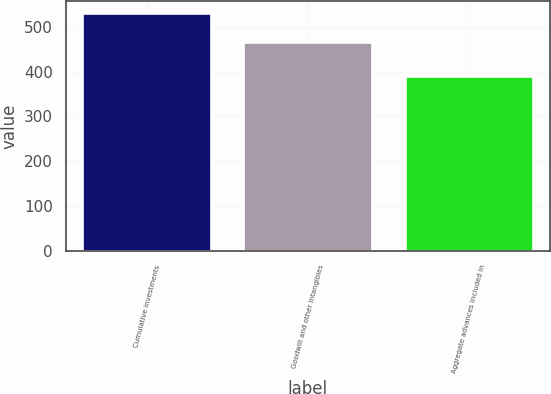Convert chart. <chart><loc_0><loc_0><loc_500><loc_500><bar_chart><fcel>Cumulative investments<fcel>Goodwill and other intangibles<fcel>Aggregate advances included in<nl><fcel>530.6<fcel>465.1<fcel>390.3<nl></chart> 